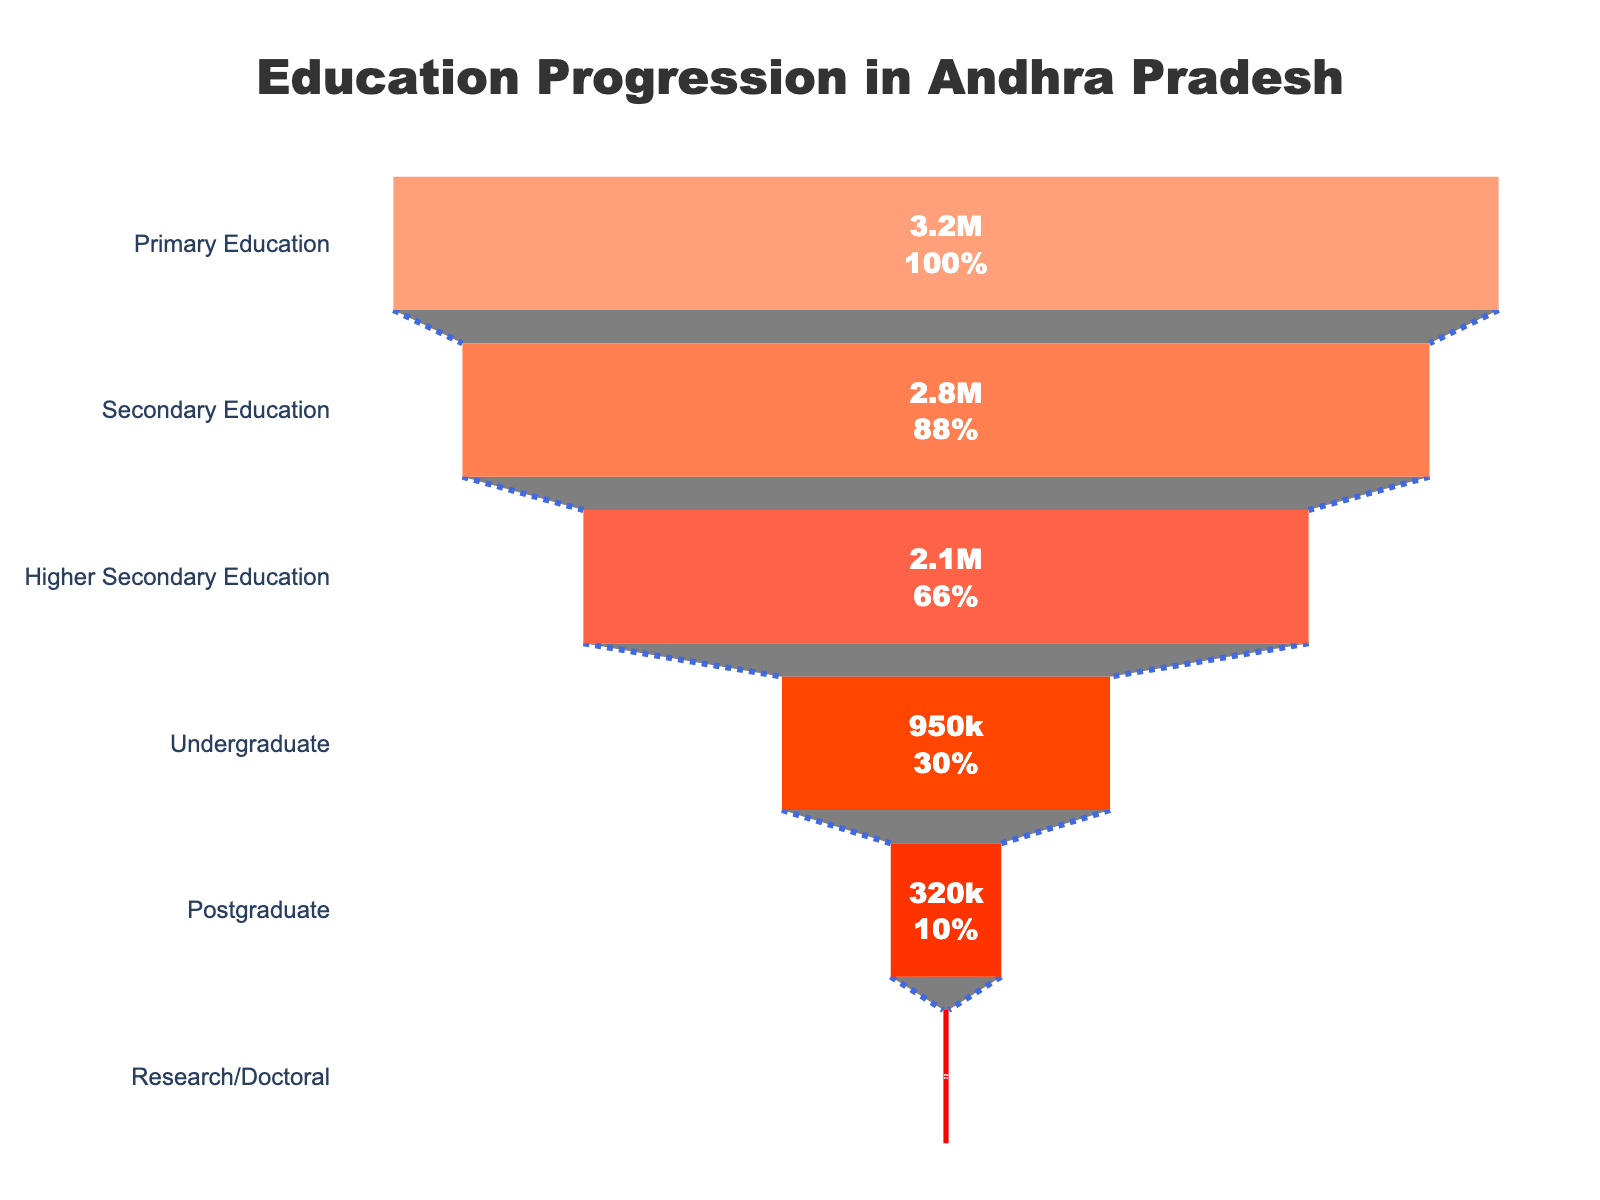How many students are enrolled in primary education? The figure shows a funnel chart detailing the number of students at different educational levels. To find the number of students in primary education, locate the corresponding section of the chart.
Answer: 3,200,000 What percentage of students from primary education continue to secondary education? Look at the percentage value shown in the funnel section that transitions from primary to secondary education.
Answer: 87.5% Which educational level has the highest dropout rate from the previous level? Compare the number of students at each subsequent educational level to find the largest decrease.
Answer: Higher secondary to undergraduate How many students are enrolled in research or doctoral programs? Locate the section of the funnel chart that corresponds to research or doctoral programs to find the exact number of students.
Answer: 15,000 What percentage of secondary education students continue to higher secondary education? Examine the percentage value displayed in the funnel section transitioning from secondary to higher secondary education.
Answer: 75% How many more students are in undergraduate programs compared to postgraduate programs? Subtract the number of students in postgraduate programs from those in undergraduate programs. 950,000 - 320,000 = 630,000
Answer: 630,000 What is the total number of students in higher secondary education and undergraduate programs combined? Add the number of students in higher secondary education and undergraduate programs. 2,100,000 + 950,000 = 3,050,000
Answer: 3,050,000 What is the smallest group of students in any educational level according to the chart? Identify the section in the funnel chart with the smallest number of students.
Answer: Research/Doctoral Compare the number of postgraduate students to those in higher secondary education. What is the ratio of postgraduate students to higher secondary students? Divide the number of postgraduate students by the number of higher secondary education students. 320,000 / 2,100,000 = 0.152
Answer: 0.152 Between which educational levels do we see the greatest absolute drop in the number of students? Calculate the differences in student numbers between each educational level and determine the greatest absolute difference.
Answer: Higher secondary to undergraduate 